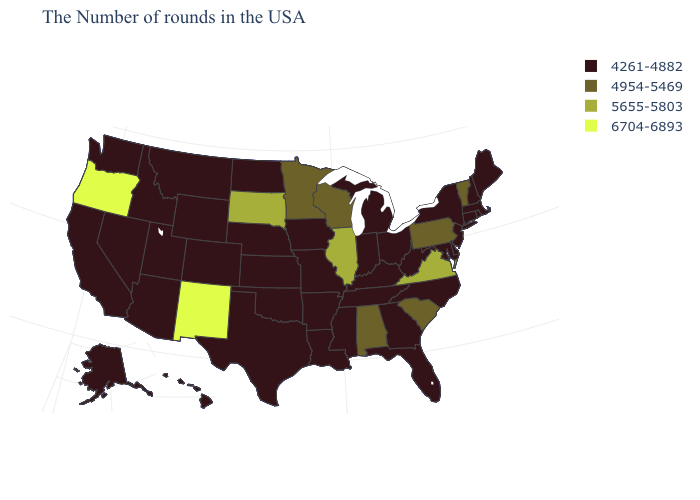What is the value of Ohio?
Answer briefly. 4261-4882. What is the value of South Dakota?
Give a very brief answer. 5655-5803. What is the highest value in the West ?
Answer briefly. 6704-6893. What is the value of Maine?
Concise answer only. 4261-4882. What is the lowest value in states that border Missouri?
Quick response, please. 4261-4882. What is the value of New Jersey?
Give a very brief answer. 4261-4882. Does the map have missing data?
Short answer required. No. What is the lowest value in states that border Michigan?
Concise answer only. 4261-4882. Which states have the lowest value in the Northeast?
Short answer required. Maine, Massachusetts, Rhode Island, New Hampshire, Connecticut, New York, New Jersey. What is the highest value in the South ?
Give a very brief answer. 5655-5803. What is the value of Iowa?
Keep it brief. 4261-4882. Does Tennessee have the same value as Virginia?
Be succinct. No. Does the map have missing data?
Answer briefly. No. Name the states that have a value in the range 4954-5469?
Answer briefly. Vermont, Pennsylvania, South Carolina, Alabama, Wisconsin, Minnesota. Among the states that border Iowa , which have the lowest value?
Give a very brief answer. Missouri, Nebraska. 